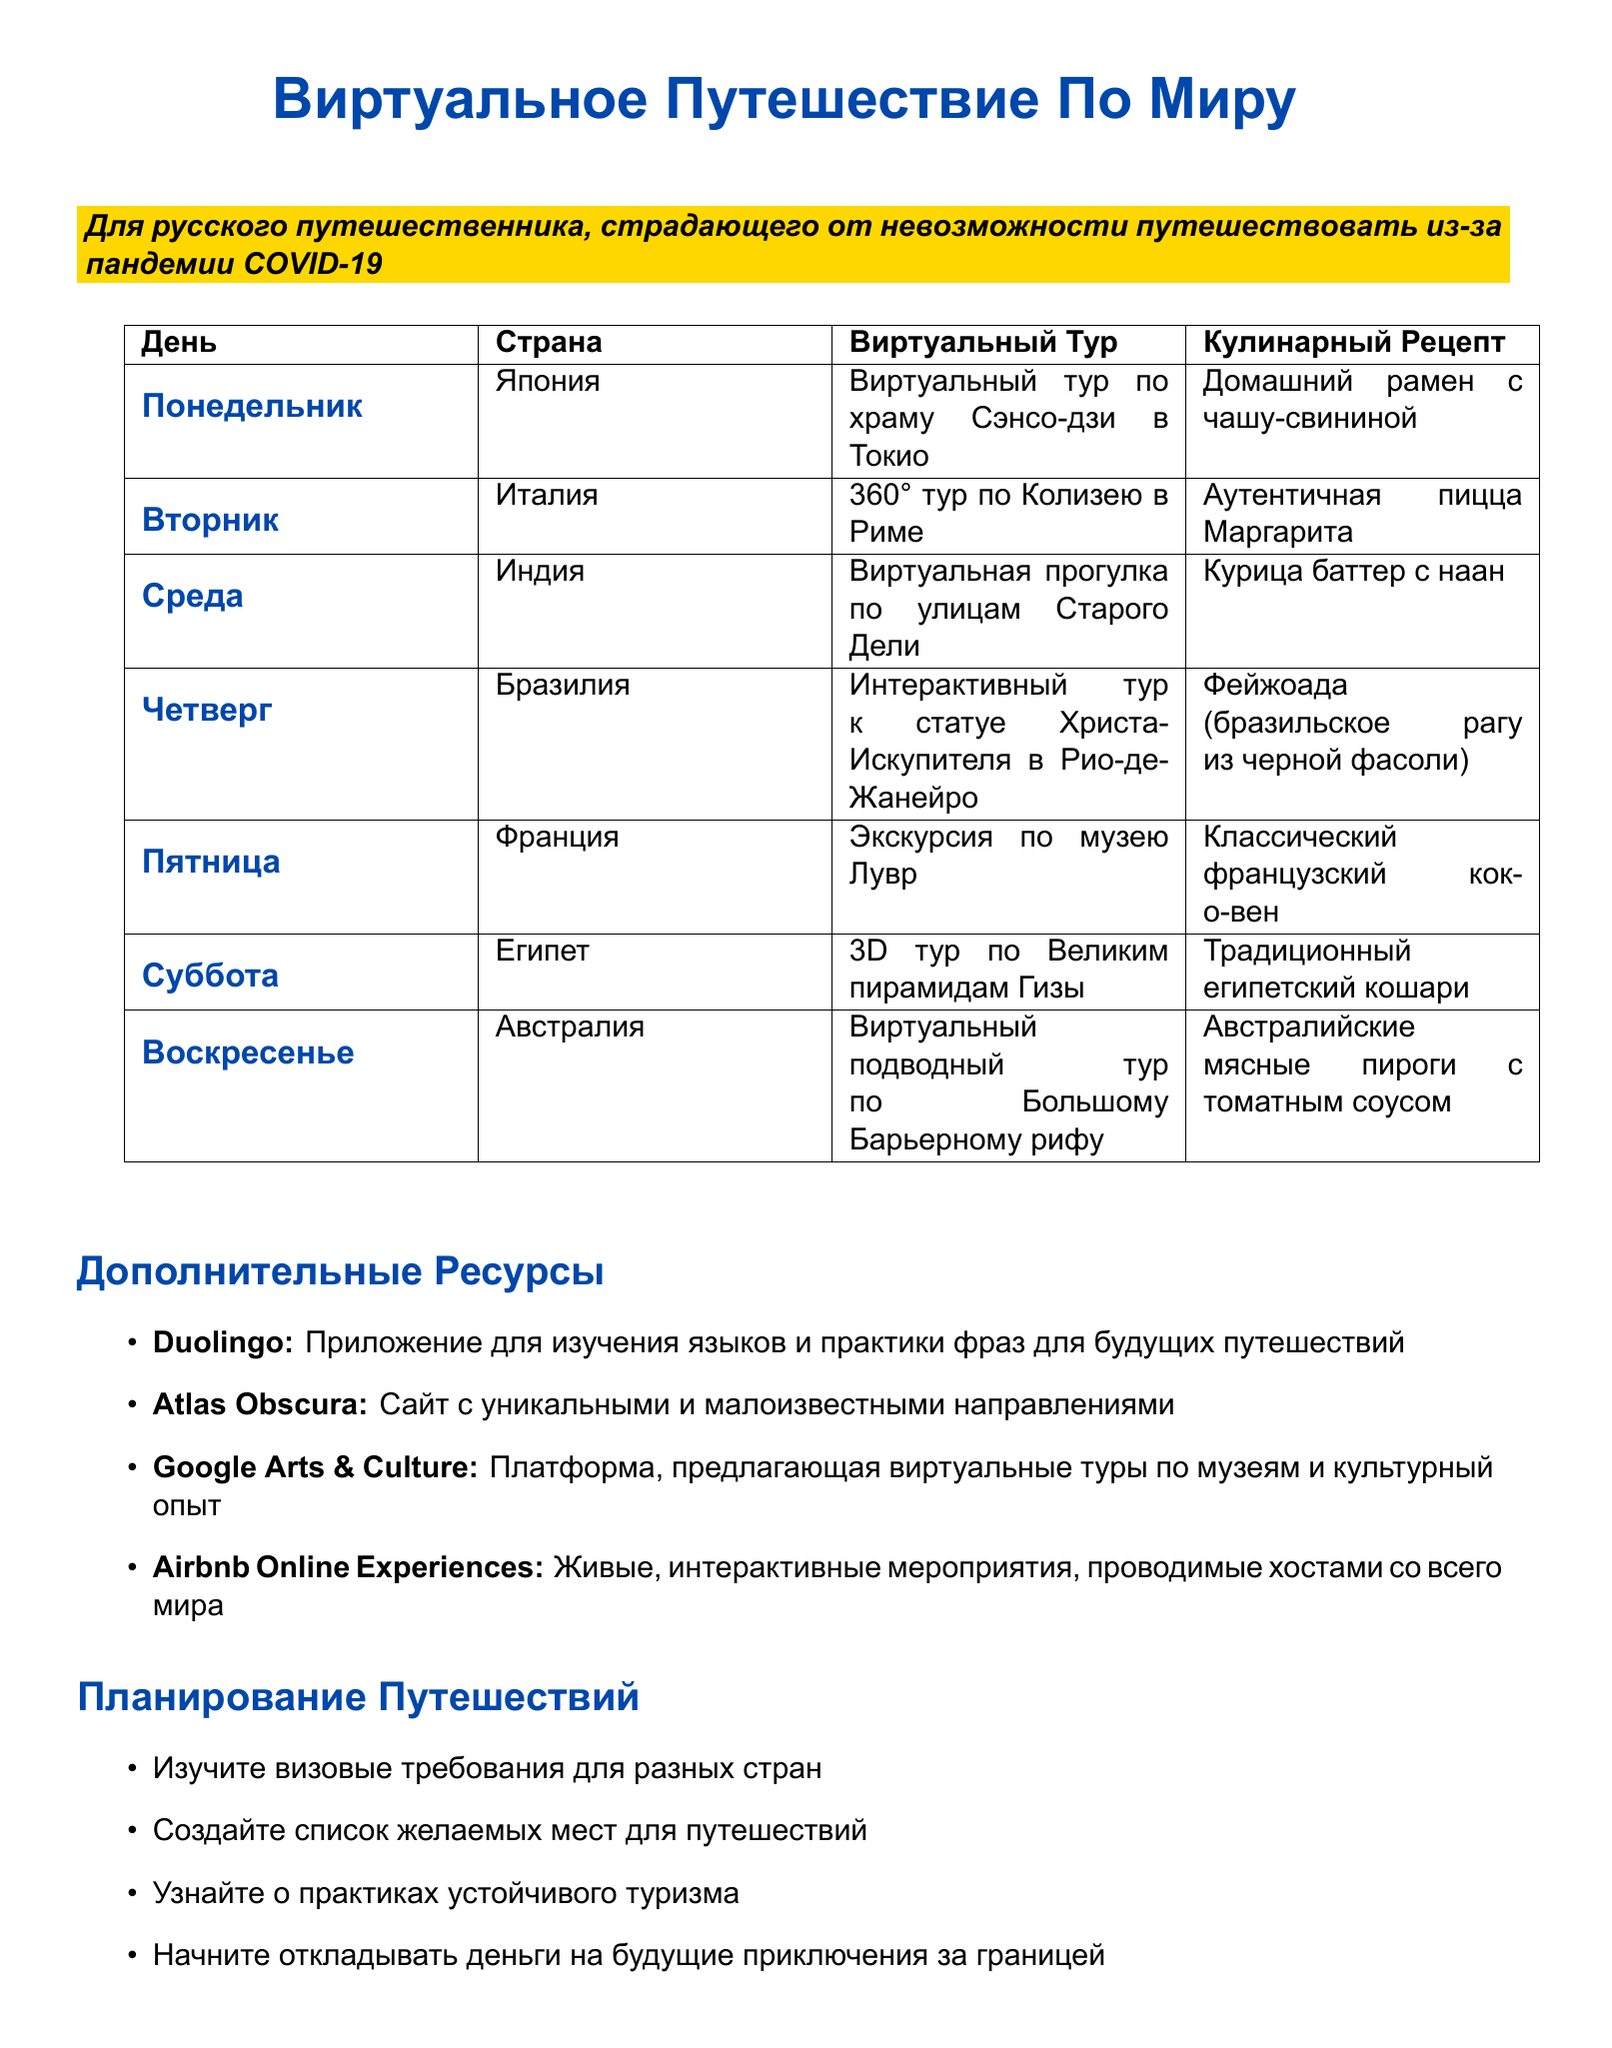What country is featured on Monday? The country for Monday in the travel itinerary is listed as Japan.
Answer: Japan What is the online tour for Italy? The document states that the online tour for Italy is a 360° tour of the Colosseum in Rome.
Answer: 360° tour of the Colosseum in Rome Which cultural activity is planned for Wednesday? The cultural activity planned for Wednesday, according to the document, is an Online Bollywood dance class.
Answer: Online Bollywood dance class What is the cuisine recipe for Saturday? The document specifies that the cuisine recipe for Saturday is Traditional Egyptian Koshari.
Answer: Traditional Egyptian Koshari How many countries are included in the itinerary? There are a total of seven countries included in the virtual travel itinerary.
Answer: Seven What type of experience is offered on Friday? The document notes that a virtual tour of the Louvre Museum is offered on Friday.
Answer: Virtual tour of the Louvre Museum What is one resource listed for language learning? The document mentions Duolingo as a resource for language learning.
Answer: Duolingo What activity is suggested for trip planning regarding finances? The document suggests starting a travel savings fund as an activity for trip planning.
Answer: Start a travel savings fund 